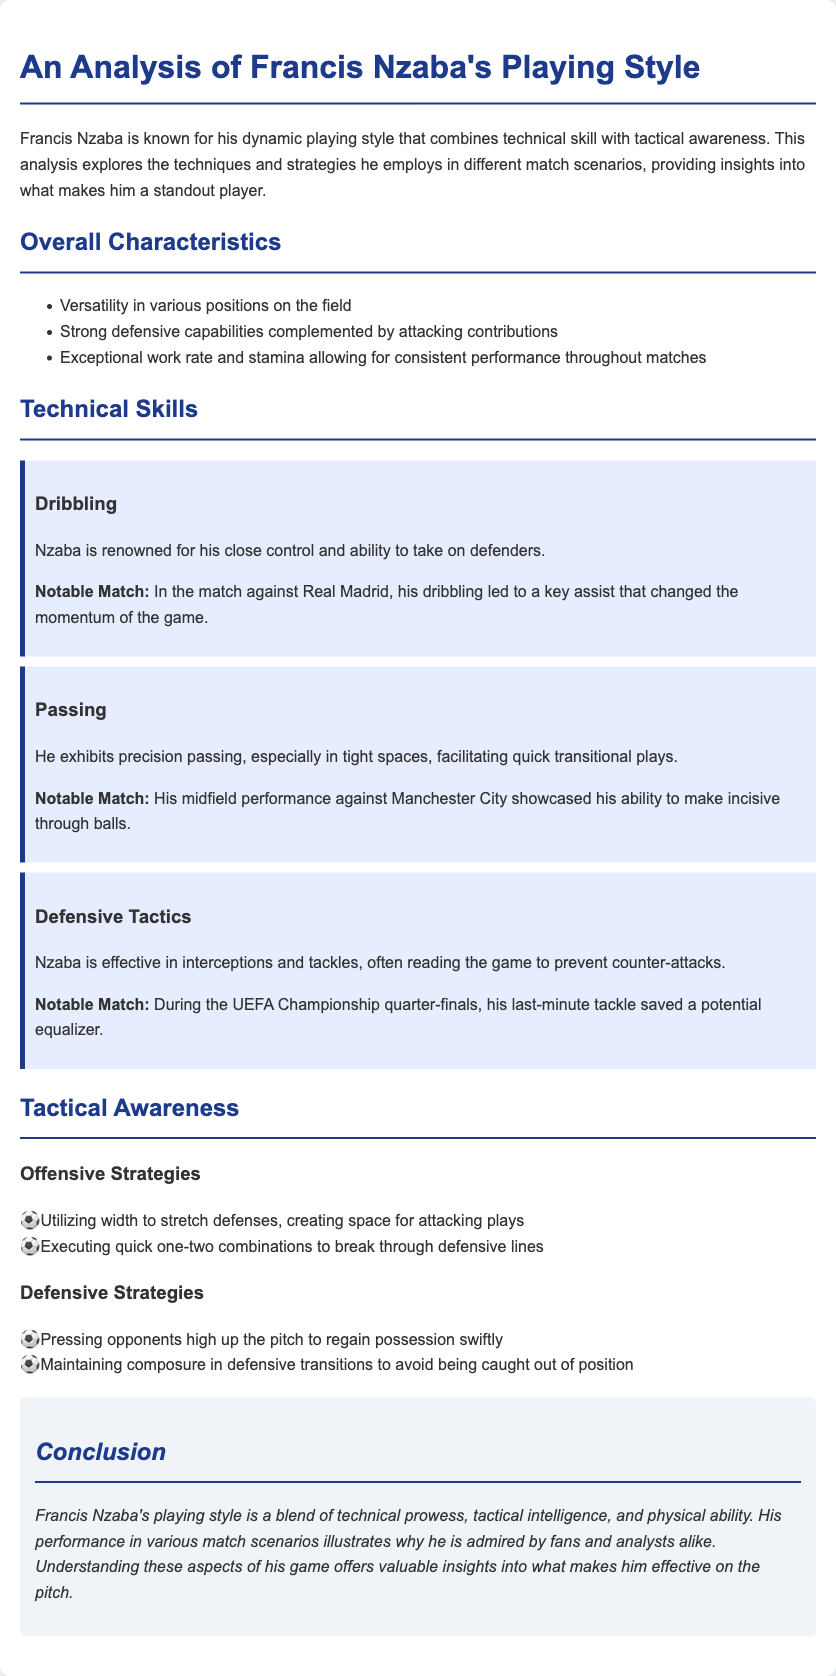What are the overall characteristics of Nzaba? The overall characteristics are listed in the section labeled "Overall Characteristics," which includes versatility, strong defensive capabilities, and exceptional work rate.
Answer: Versatility in various positions on the field, strong defensive capabilities complemented by attacking contributions, exceptional work rate and stamina allowing for consistent performance throughout matches What is Nzaba renowned for in technical skills? The technical skills section highlights Nzaba's dribbling, passing, and defensive tactics.
Answer: His close control and ability to take on defenders In which notable match did Nzaba demonstrate his dribbling skill? The document mentions a specific match against Real Madrid, where his dribbling led to a key assist.
Answer: Against Real Madrid What type of strategies does Nzaba utilize offensively? The "Offensive Strategies" section lists tactics such as utilizing width and executing quick one-two combinations.
Answer: Utilizing width to stretch defenses, creating space for attacking plays What defensive strategy does Nzaba employ? The defensive strategies section includes pressing opponents high up the pitch to regain possession swiftly.
Answer: Pressing opponents high up the pitch to regain possession swiftly What is the conclusion regarding Nzaba's playing style? The conclusion summarizes his playing style as a blend of technical prowess, tactical intelligence, and physical ability.
Answer: A blend of technical prowess, tactical intelligence, and physical ability How does Nzaba maintain his defensive composure? The "Defensive Strategies" section mentions maintaining composure in defensive transitions to avoid being caught out of position.
Answer: Maintaining composure in defensive transitions to avoid being caught out of position What is highlighted about Nzaba's passing ability? The document states that he exhibits precision passing, particularly in tight spaces for quick plays.
Answer: Precision passing, especially in tight spaces 